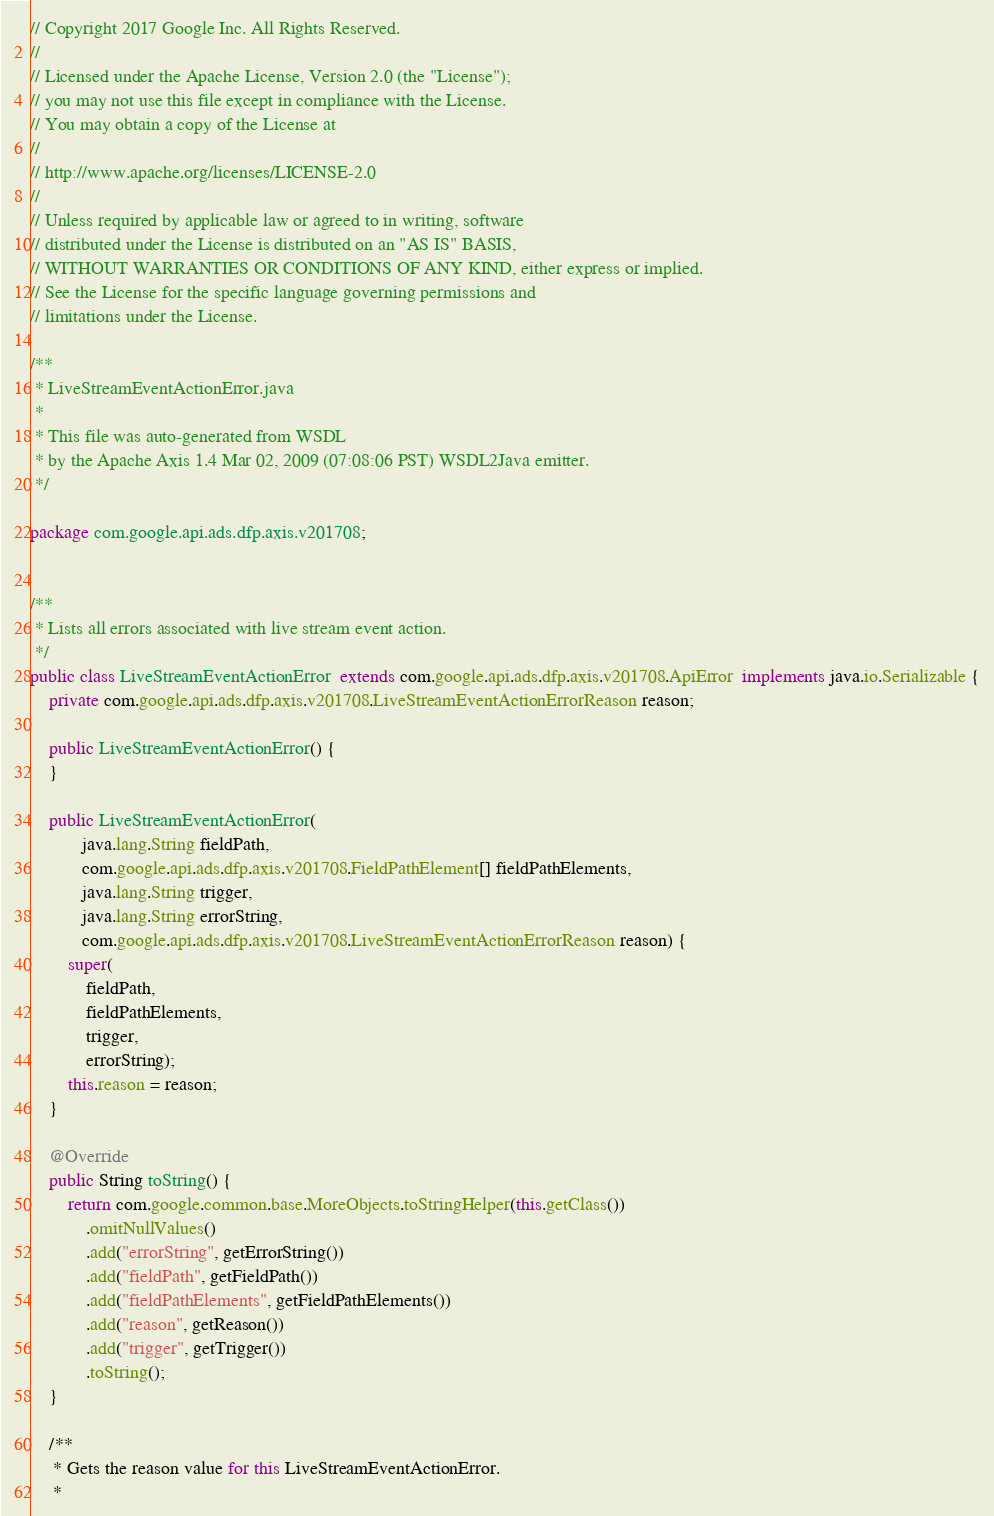Convert code to text. <code><loc_0><loc_0><loc_500><loc_500><_Java_>// Copyright 2017 Google Inc. All Rights Reserved.
//
// Licensed under the Apache License, Version 2.0 (the "License");
// you may not use this file except in compliance with the License.
// You may obtain a copy of the License at
//
// http://www.apache.org/licenses/LICENSE-2.0
//
// Unless required by applicable law or agreed to in writing, software
// distributed under the License is distributed on an "AS IS" BASIS,
// WITHOUT WARRANTIES OR CONDITIONS OF ANY KIND, either express or implied.
// See the License for the specific language governing permissions and
// limitations under the License.

/**
 * LiveStreamEventActionError.java
 *
 * This file was auto-generated from WSDL
 * by the Apache Axis 1.4 Mar 02, 2009 (07:08:06 PST) WSDL2Java emitter.
 */

package com.google.api.ads.dfp.axis.v201708;


/**
 * Lists all errors associated with live stream event action.
 */
public class LiveStreamEventActionError  extends com.google.api.ads.dfp.axis.v201708.ApiError  implements java.io.Serializable {
    private com.google.api.ads.dfp.axis.v201708.LiveStreamEventActionErrorReason reason;

    public LiveStreamEventActionError() {
    }

    public LiveStreamEventActionError(
           java.lang.String fieldPath,
           com.google.api.ads.dfp.axis.v201708.FieldPathElement[] fieldPathElements,
           java.lang.String trigger,
           java.lang.String errorString,
           com.google.api.ads.dfp.axis.v201708.LiveStreamEventActionErrorReason reason) {
        super(
            fieldPath,
            fieldPathElements,
            trigger,
            errorString);
        this.reason = reason;
    }

    @Override
    public String toString() {
        return com.google.common.base.MoreObjects.toStringHelper(this.getClass())
            .omitNullValues()
            .add("errorString", getErrorString())
            .add("fieldPath", getFieldPath())
            .add("fieldPathElements", getFieldPathElements())
            .add("reason", getReason())
            .add("trigger", getTrigger())
            .toString();
    }

    /**
     * Gets the reason value for this LiveStreamEventActionError.
     * </code> 